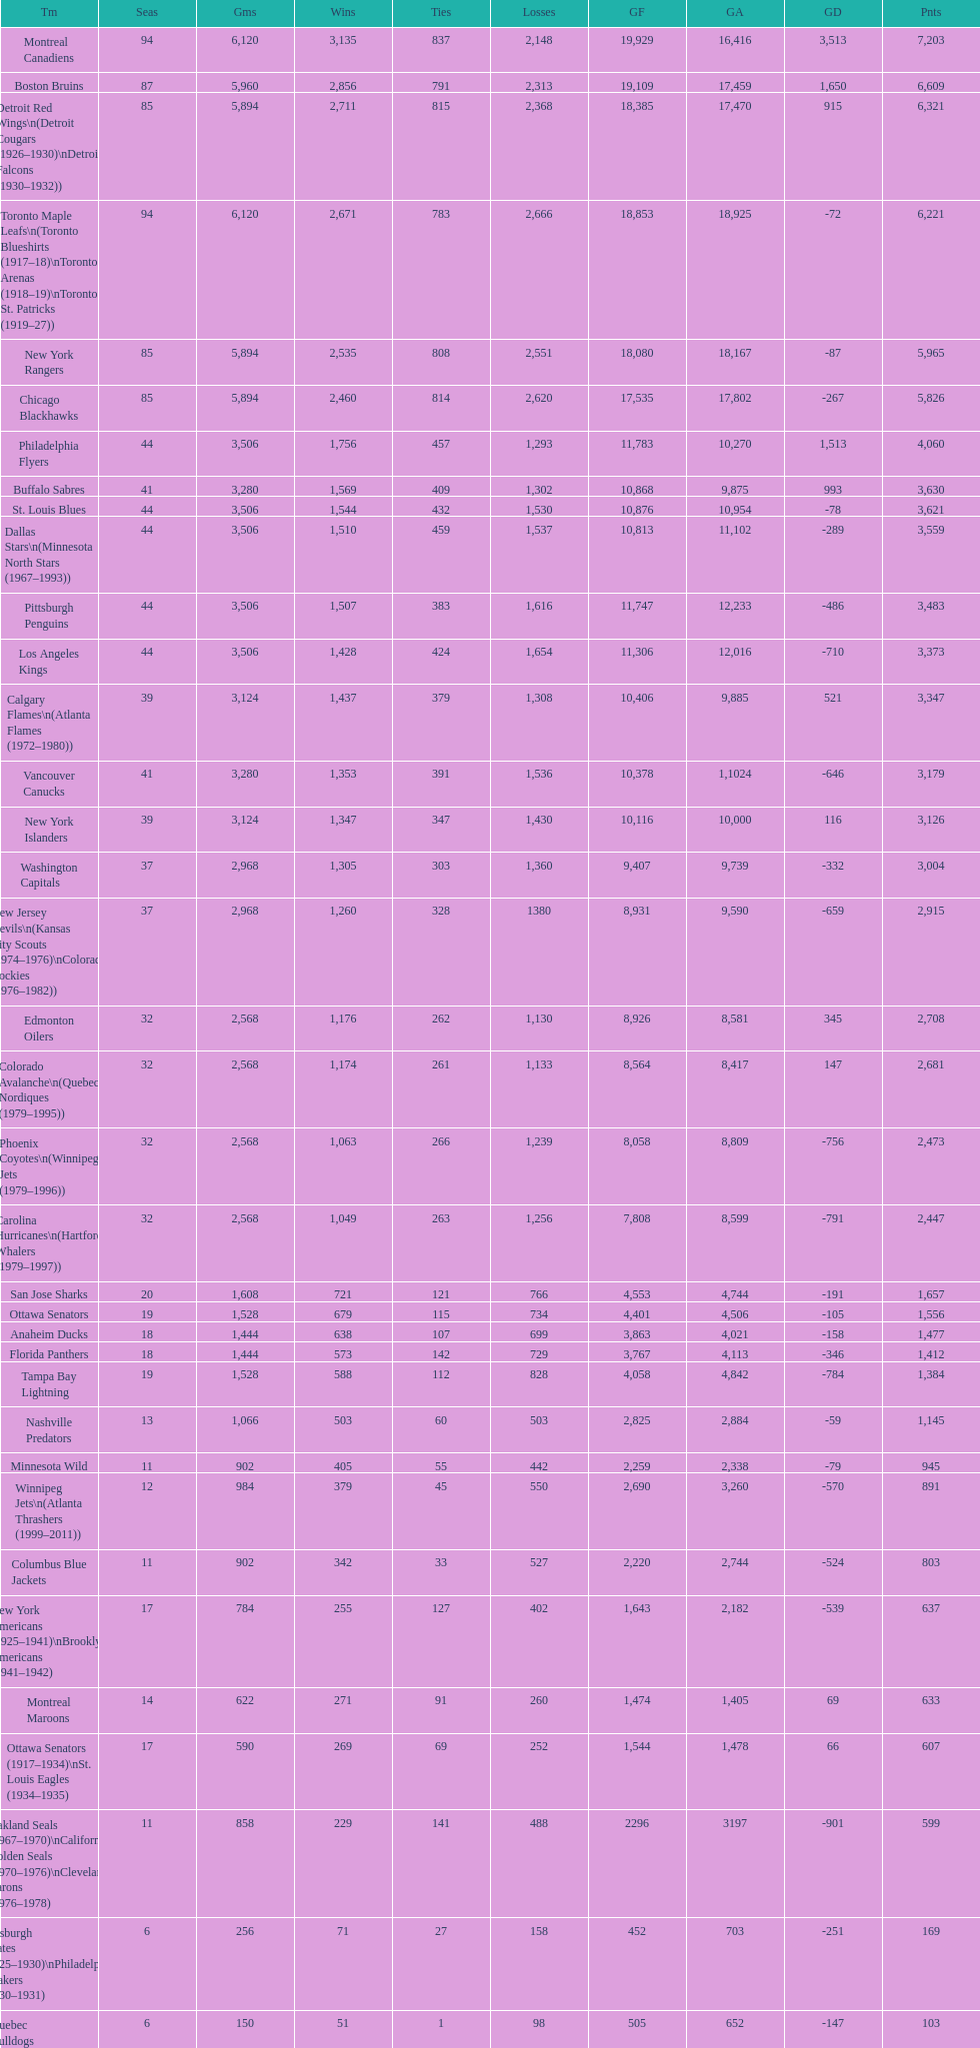Who is at the top of the list? Montreal Canadiens. Can you give me this table as a dict? {'header': ['Tm', 'Seas', 'Gms', 'Wins', 'Ties', 'Losses', 'GF', 'GA', 'GD', 'Pnts'], 'rows': [['Montreal Canadiens', '94', '6,120', '3,135', '837', '2,148', '19,929', '16,416', '3,513', '7,203'], ['Boston Bruins', '87', '5,960', '2,856', '791', '2,313', '19,109', '17,459', '1,650', '6,609'], ['Detroit Red Wings\\n(Detroit Cougars (1926–1930)\\nDetroit Falcons (1930–1932))', '85', '5,894', '2,711', '815', '2,368', '18,385', '17,470', '915', '6,321'], ['Toronto Maple Leafs\\n(Toronto Blueshirts (1917–18)\\nToronto Arenas (1918–19)\\nToronto St. Patricks (1919–27))', '94', '6,120', '2,671', '783', '2,666', '18,853', '18,925', '-72', '6,221'], ['New York Rangers', '85', '5,894', '2,535', '808', '2,551', '18,080', '18,167', '-87', '5,965'], ['Chicago Blackhawks', '85', '5,894', '2,460', '814', '2,620', '17,535', '17,802', '-267', '5,826'], ['Philadelphia Flyers', '44', '3,506', '1,756', '457', '1,293', '11,783', '10,270', '1,513', '4,060'], ['Buffalo Sabres', '41', '3,280', '1,569', '409', '1,302', '10,868', '9,875', '993', '3,630'], ['St. Louis Blues', '44', '3,506', '1,544', '432', '1,530', '10,876', '10,954', '-78', '3,621'], ['Dallas Stars\\n(Minnesota North Stars (1967–1993))', '44', '3,506', '1,510', '459', '1,537', '10,813', '11,102', '-289', '3,559'], ['Pittsburgh Penguins', '44', '3,506', '1,507', '383', '1,616', '11,747', '12,233', '-486', '3,483'], ['Los Angeles Kings', '44', '3,506', '1,428', '424', '1,654', '11,306', '12,016', '-710', '3,373'], ['Calgary Flames\\n(Atlanta Flames (1972–1980))', '39', '3,124', '1,437', '379', '1,308', '10,406', '9,885', '521', '3,347'], ['Vancouver Canucks', '41', '3,280', '1,353', '391', '1,536', '10,378', '1,1024', '-646', '3,179'], ['New York Islanders', '39', '3,124', '1,347', '347', '1,430', '10,116', '10,000', '116', '3,126'], ['Washington Capitals', '37', '2,968', '1,305', '303', '1,360', '9,407', '9,739', '-332', '3,004'], ['New Jersey Devils\\n(Kansas City Scouts (1974–1976)\\nColorado Rockies (1976–1982))', '37', '2,968', '1,260', '328', '1380', '8,931', '9,590', '-659', '2,915'], ['Edmonton Oilers', '32', '2,568', '1,176', '262', '1,130', '8,926', '8,581', '345', '2,708'], ['Colorado Avalanche\\n(Quebec Nordiques (1979–1995))', '32', '2,568', '1,174', '261', '1,133', '8,564', '8,417', '147', '2,681'], ['Phoenix Coyotes\\n(Winnipeg Jets (1979–1996))', '32', '2,568', '1,063', '266', '1,239', '8,058', '8,809', '-756', '2,473'], ['Carolina Hurricanes\\n(Hartford Whalers (1979–1997))', '32', '2,568', '1,049', '263', '1,256', '7,808', '8,599', '-791', '2,447'], ['San Jose Sharks', '20', '1,608', '721', '121', '766', '4,553', '4,744', '-191', '1,657'], ['Ottawa Senators', '19', '1,528', '679', '115', '734', '4,401', '4,506', '-105', '1,556'], ['Anaheim Ducks', '18', '1,444', '638', '107', '699', '3,863', '4,021', '-158', '1,477'], ['Florida Panthers', '18', '1,444', '573', '142', '729', '3,767', '4,113', '-346', '1,412'], ['Tampa Bay Lightning', '19', '1,528', '588', '112', '828', '4,058', '4,842', '-784', '1,384'], ['Nashville Predators', '13', '1,066', '503', '60', '503', '2,825', '2,884', '-59', '1,145'], ['Minnesota Wild', '11', '902', '405', '55', '442', '2,259', '2,338', '-79', '945'], ['Winnipeg Jets\\n(Atlanta Thrashers (1999–2011))', '12', '984', '379', '45', '550', '2,690', '3,260', '-570', '891'], ['Columbus Blue Jackets', '11', '902', '342', '33', '527', '2,220', '2,744', '-524', '803'], ['New York Americans (1925–1941)\\nBrooklyn Americans (1941–1942)', '17', '784', '255', '127', '402', '1,643', '2,182', '-539', '637'], ['Montreal Maroons', '14', '622', '271', '91', '260', '1,474', '1,405', '69', '633'], ['Ottawa Senators (1917–1934)\\nSt. Louis Eagles (1934–1935)', '17', '590', '269', '69', '252', '1,544', '1,478', '66', '607'], ['Oakland Seals (1967–1970)\\nCalifornia Golden Seals (1970–1976)\\nCleveland Barons (1976–1978)', '11', '858', '229', '141', '488', '2296', '3197', '-901', '599'], ['Pittsburgh Pirates (1925–1930)\\nPhiladelphia Quakers (1930–1931)', '6', '256', '71', '27', '158', '452', '703', '-251', '169'], ['Quebec Bulldogs (1919–1920)\\nHamilton Tigers (1920–1925)', '6', '150', '51', '1', '98', '505', '652', '-147', '103'], ['Montreal Wanderers', '1', '6', '1', '0', '5', '17', '35', '-18', '2']]} 